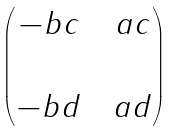Convert formula to latex. <formula><loc_0><loc_0><loc_500><loc_500>\begin{pmatrix} - b c & & a c \\ \\ - b d & & a d \end{pmatrix}</formula> 